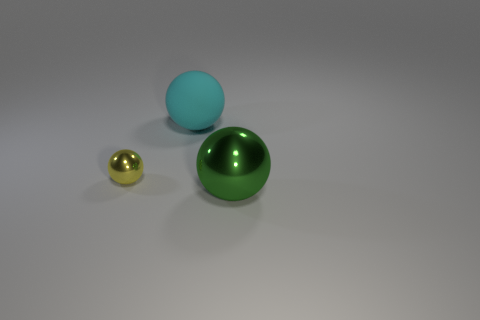How many objects are small things or metallic balls to the right of the big matte object?
Your answer should be compact. 2. Does the thing right of the cyan ball have the same size as the ball that is on the left side of the rubber ball?
Your response must be concise. No. What number of large green things have the same shape as the small thing?
Make the answer very short. 1. What is the shape of the tiny yellow object that is the same material as the large green ball?
Keep it short and to the point. Sphere. What is the material of the big object behind the large object in front of the metal thing to the left of the rubber thing?
Your answer should be compact. Rubber. There is a green metal thing; is it the same size as the shiny object that is left of the big green shiny thing?
Provide a short and direct response. No. What material is the small object that is the same shape as the big cyan thing?
Give a very brief answer. Metal. There is a metal object behind the ball to the right of the large thing behind the small ball; how big is it?
Offer a terse response. Small. Do the green metallic thing and the rubber sphere have the same size?
Provide a short and direct response. Yes. What material is the large object that is in front of the matte object behind the tiny shiny ball?
Provide a succinct answer. Metal. 